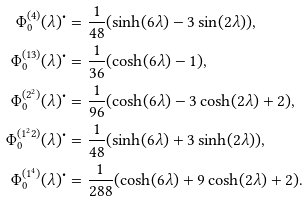Convert formula to latex. <formula><loc_0><loc_0><loc_500><loc_500>\Phi ^ { ( 4 ) } _ { 0 } ( \lambda ) ^ { \bullet } & = \frac { 1 } { 4 8 } ( \sinh ( 6 \lambda ) - 3 \sin ( 2 \lambda ) ) , \\ \Phi ^ { ( 1 3 ) } _ { 0 } ( \lambda ) ^ { \bullet } & = \frac { 1 } { 3 6 } ( \cosh ( 6 \lambda ) - 1 ) , \\ \Phi ^ { ( 2 ^ { 2 } ) } _ { 0 } ( \lambda ) ^ { \bullet } & = \frac { 1 } { 9 6 } ( \cosh ( 6 \lambda ) - 3 \cosh ( 2 \lambda ) + 2 ) , \\ \Phi ^ { ( 1 ^ { 2 } 2 ) } _ { 0 } ( \lambda ) ^ { \bullet } & = \frac { 1 } { 4 8 } ( \sinh ( 6 \lambda ) + 3 \sinh ( 2 \lambda ) ) , \\ \Phi ^ { ( 1 ^ { 4 } ) } _ { 0 } ( \lambda ) ^ { \bullet } & = \frac { 1 } { 2 8 8 } ( \cosh ( 6 \lambda ) + 9 \cosh ( 2 \lambda ) + 2 ) .</formula> 